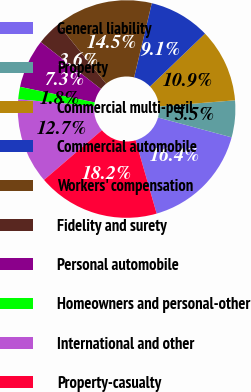<chart> <loc_0><loc_0><loc_500><loc_500><pie_chart><fcel>General liability<fcel>Property<fcel>Commercial multi-peril<fcel>Commercial automobile<fcel>Workers' compensation<fcel>Fidelity and surety<fcel>Personal automobile<fcel>Homeowners and personal-other<fcel>International and other<fcel>Property-casualty<nl><fcel>16.35%<fcel>5.47%<fcel>10.91%<fcel>9.09%<fcel>14.53%<fcel>3.65%<fcel>7.28%<fcel>1.84%<fcel>12.72%<fcel>18.16%<nl></chart> 